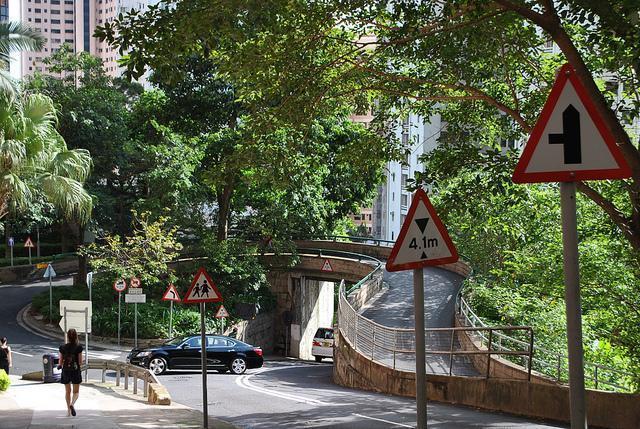How many motorcycles are there?
Give a very brief answer. 0. 